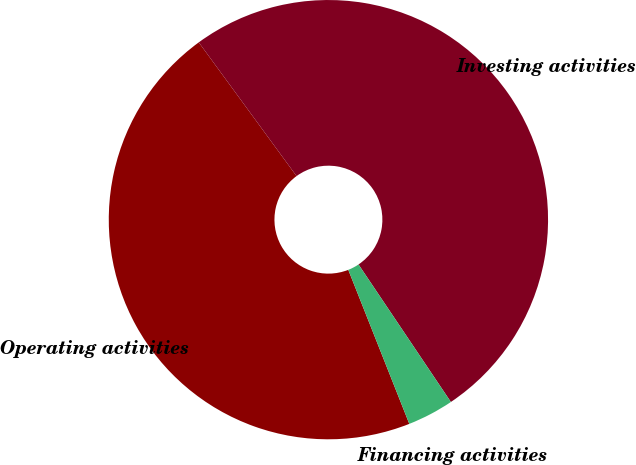<chart> <loc_0><loc_0><loc_500><loc_500><pie_chart><fcel>Operating activities<fcel>Investing activities<fcel>Financing activities<nl><fcel>45.95%<fcel>50.63%<fcel>3.41%<nl></chart> 